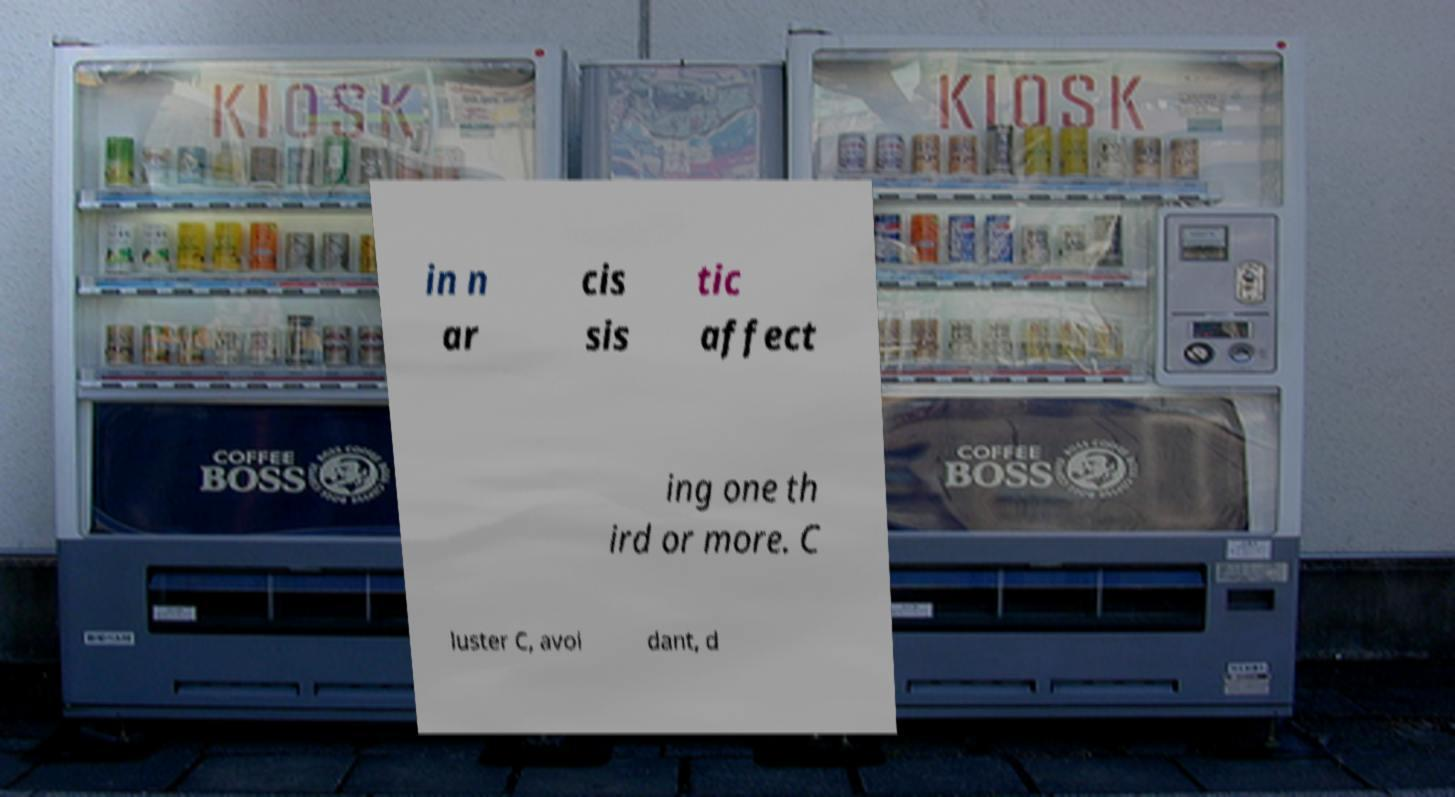What messages or text are displayed in this image? I need them in a readable, typed format. in n ar cis sis tic affect ing one th ird or more. C luster C, avoi dant, d 